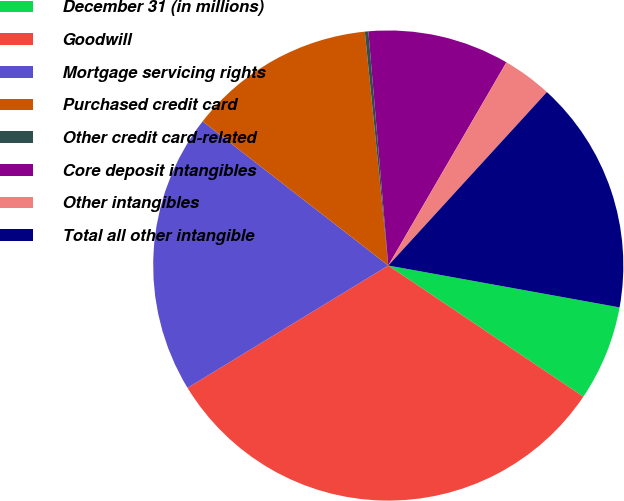Convert chart. <chart><loc_0><loc_0><loc_500><loc_500><pie_chart><fcel>December 31 (in millions)<fcel>Goodwill<fcel>Mortgage servicing rights<fcel>Purchased credit card<fcel>Other credit card-related<fcel>Core deposit intangibles<fcel>Other intangibles<fcel>Total all other intangible<nl><fcel>6.57%<fcel>31.87%<fcel>19.22%<fcel>12.9%<fcel>0.24%<fcel>9.73%<fcel>3.41%<fcel>16.06%<nl></chart> 